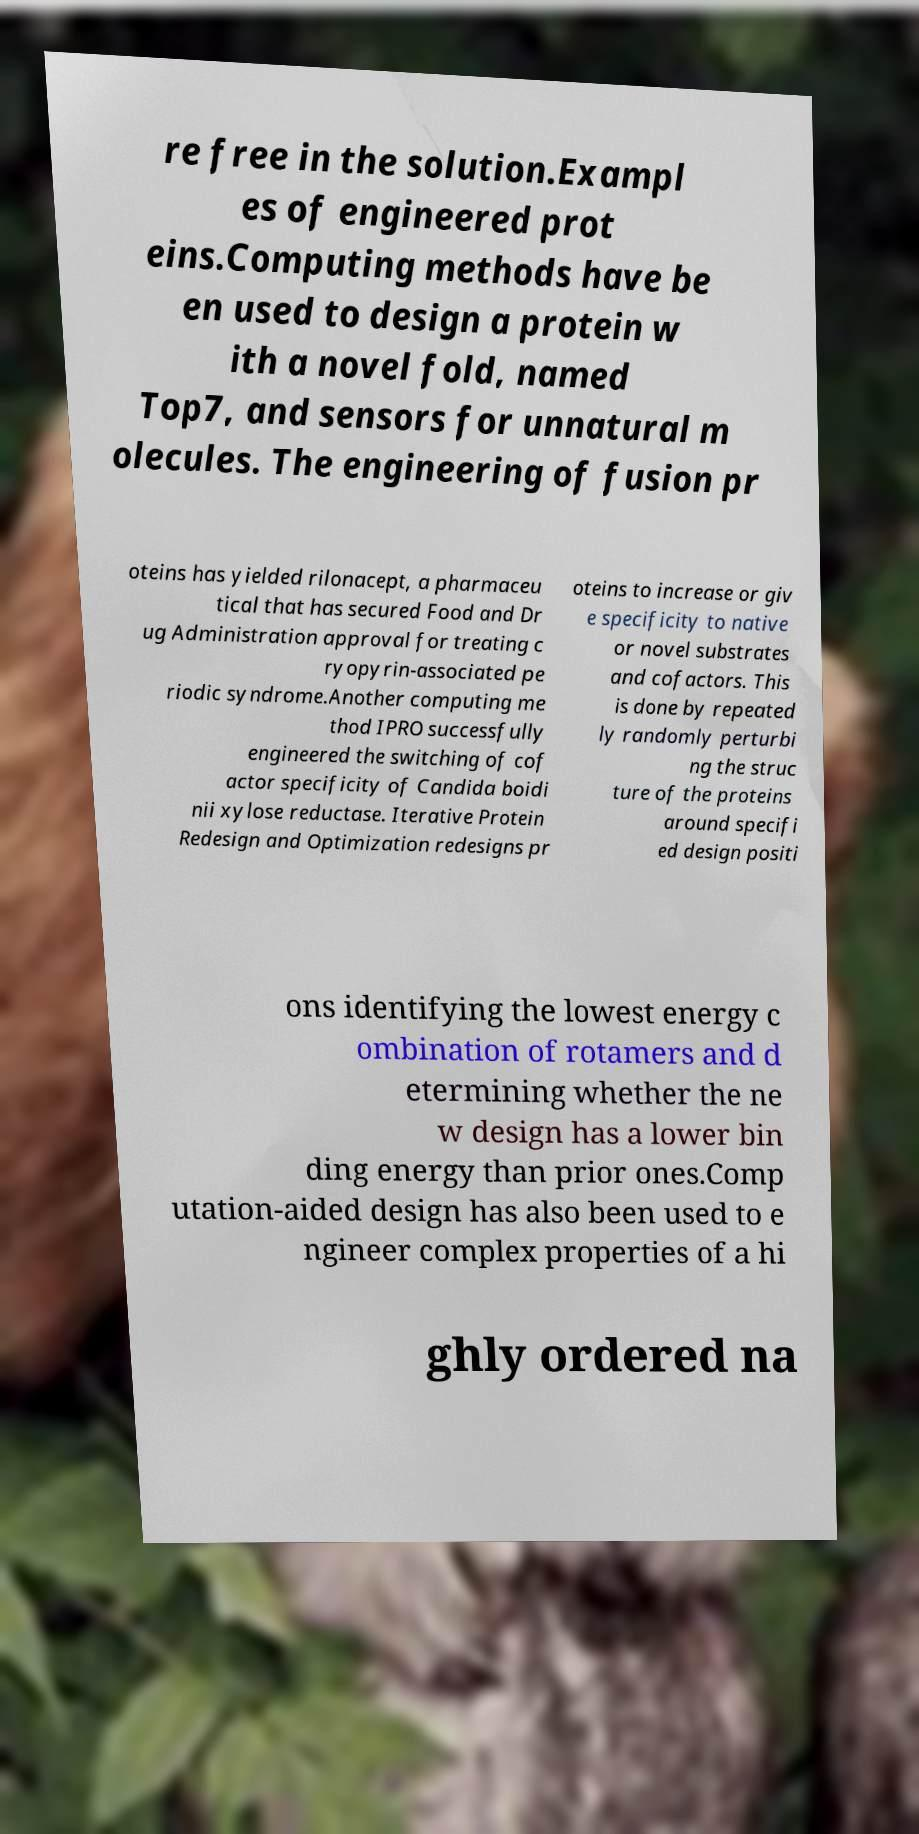Can you read and provide the text displayed in the image?This photo seems to have some interesting text. Can you extract and type it out for me? re free in the solution.Exampl es of engineered prot eins.Computing methods have be en used to design a protein w ith a novel fold, named Top7, and sensors for unnatural m olecules. The engineering of fusion pr oteins has yielded rilonacept, a pharmaceu tical that has secured Food and Dr ug Administration approval for treating c ryopyrin-associated pe riodic syndrome.Another computing me thod IPRO successfully engineered the switching of cof actor specificity of Candida boidi nii xylose reductase. Iterative Protein Redesign and Optimization redesigns pr oteins to increase or giv e specificity to native or novel substrates and cofactors. This is done by repeated ly randomly perturbi ng the struc ture of the proteins around specifi ed design positi ons identifying the lowest energy c ombination of rotamers and d etermining whether the ne w design has a lower bin ding energy than prior ones.Comp utation-aided design has also been used to e ngineer complex properties of a hi ghly ordered na 